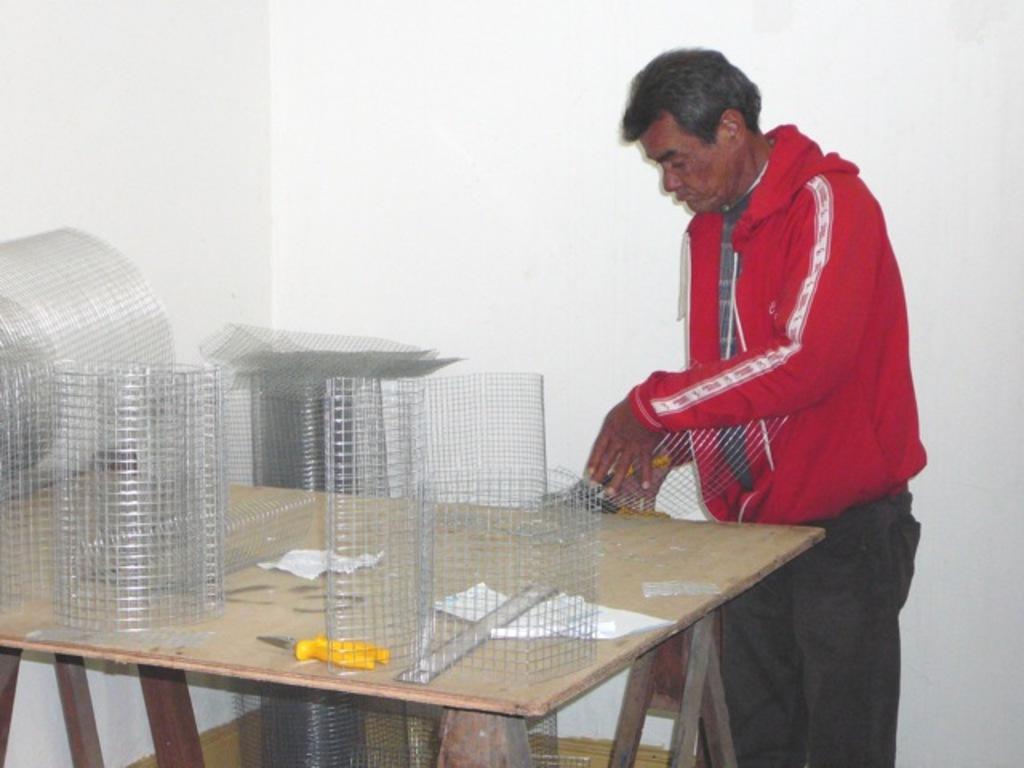How would you summarize this image in a sentence or two? This is a wall. here we can see a man wearing a red colour jacket,standing in front of a table and on the table we can see mesh, scissors, scale, paper. This man is holding a mesh in his hand. 